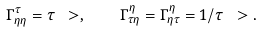<formula> <loc_0><loc_0><loc_500><loc_500>\Gamma ^ { \tau } _ { \eta \eta } = \tau \ > , \quad \Gamma ^ { \eta } _ { \tau \eta } = \Gamma ^ { \eta } _ { \eta \tau } = 1 / \tau \ > .</formula> 